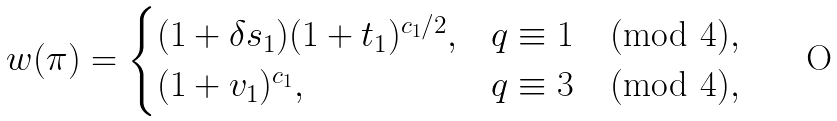<formula> <loc_0><loc_0><loc_500><loc_500>w ( \pi ) = \begin{cases} ( 1 + \delta s _ { 1 } ) ( 1 + t _ { 1 } ) ^ { c _ { 1 } / 2 } , & q \equiv 1 \pmod { 4 } , \\ ( 1 + v _ { 1 } ) ^ { c _ { 1 } } , & q \equiv 3 \pmod { 4 } , \end{cases}</formula> 